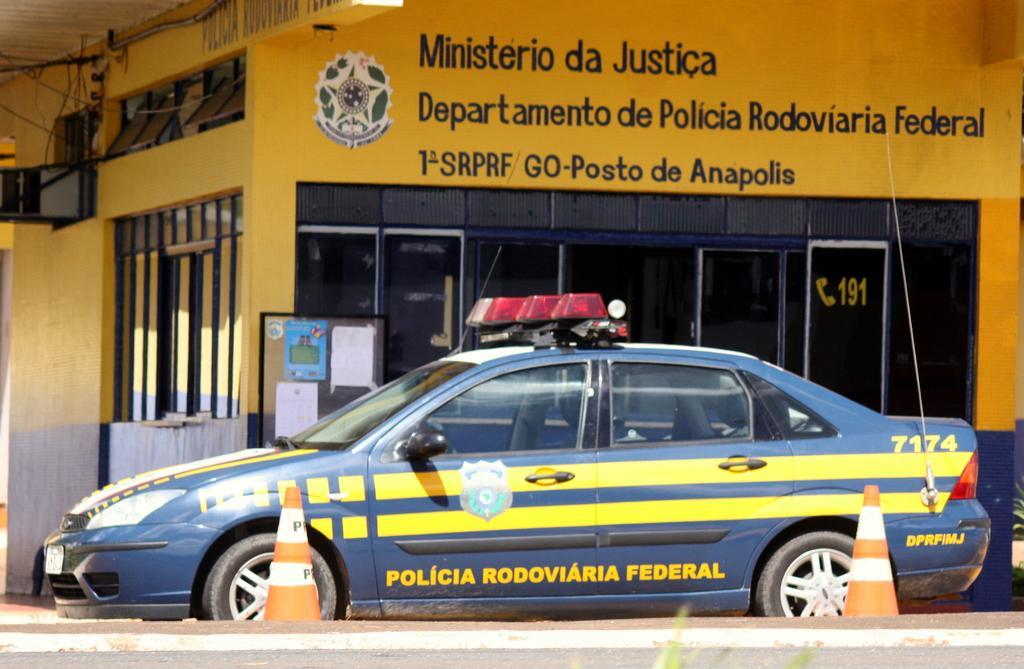Please provide a concise description of this image. In the image in the center, we can see one car and we can see traffic poles. In the background there is a building, wall, roof, banner, glass, board, posters etc. 